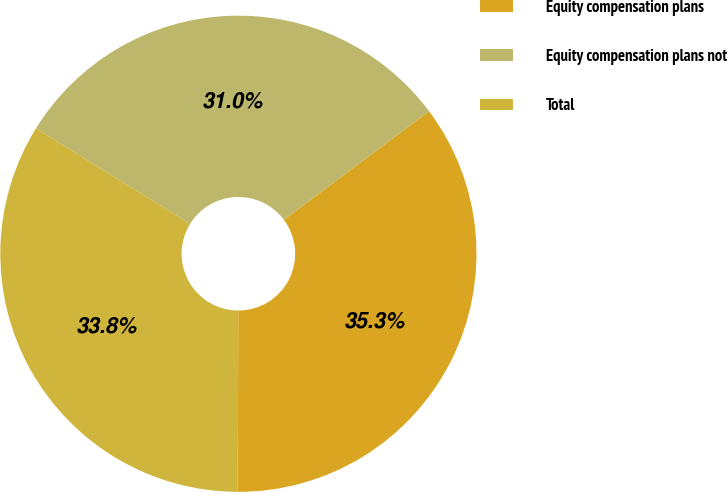<chart> <loc_0><loc_0><loc_500><loc_500><pie_chart><fcel>Equity compensation plans<fcel>Equity compensation plans not<fcel>Total<nl><fcel>35.26%<fcel>30.96%<fcel>33.78%<nl></chart> 